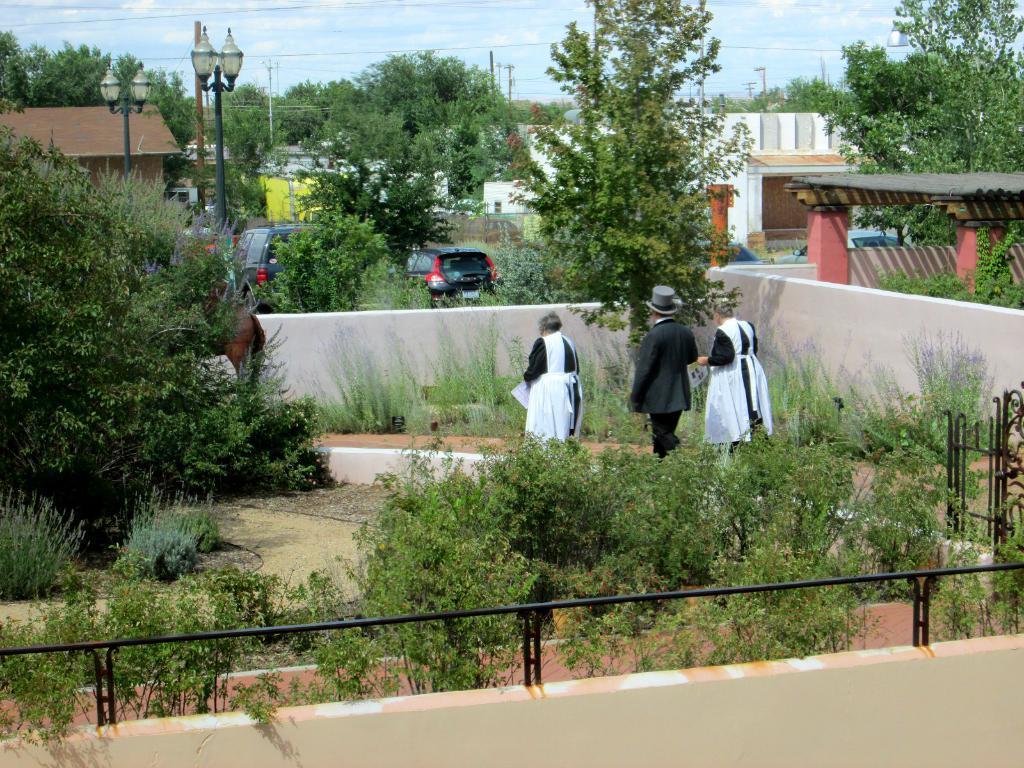Describe this image in one or two sentences. In this picture we can see plants, walls, trees, vehicles, light poles, buildings, papers, cap and three people and some objects and in the background we can see the sky. 